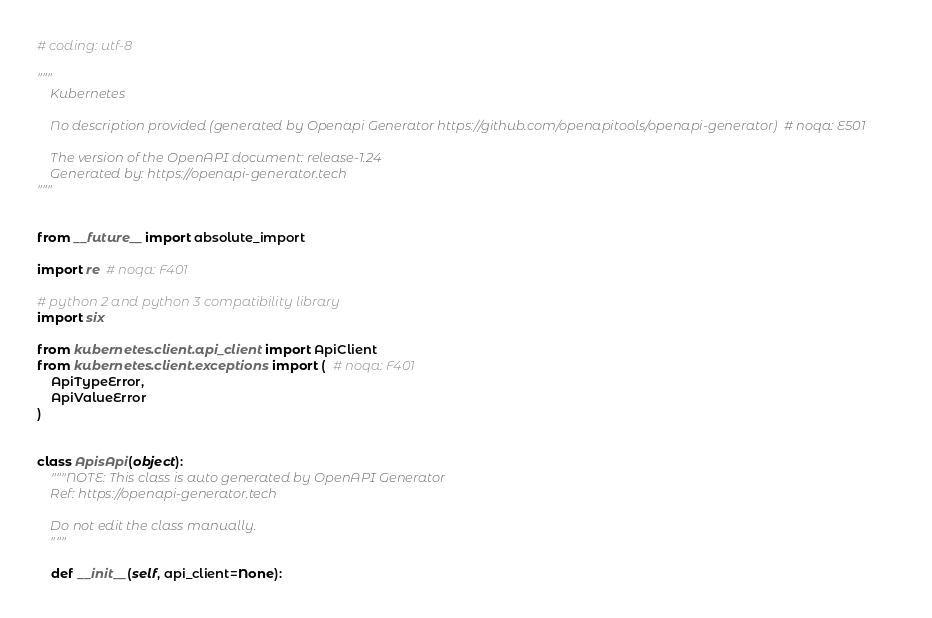<code> <loc_0><loc_0><loc_500><loc_500><_Python_># coding: utf-8

"""
    Kubernetes

    No description provided (generated by Openapi Generator https://github.com/openapitools/openapi-generator)  # noqa: E501

    The version of the OpenAPI document: release-1.24
    Generated by: https://openapi-generator.tech
"""


from __future__ import absolute_import

import re  # noqa: F401

# python 2 and python 3 compatibility library
import six

from kubernetes.client.api_client import ApiClient
from kubernetes.client.exceptions import (  # noqa: F401
    ApiTypeError,
    ApiValueError
)


class ApisApi(object):
    """NOTE: This class is auto generated by OpenAPI Generator
    Ref: https://openapi-generator.tech

    Do not edit the class manually.
    """

    def __init__(self, api_client=None):</code> 